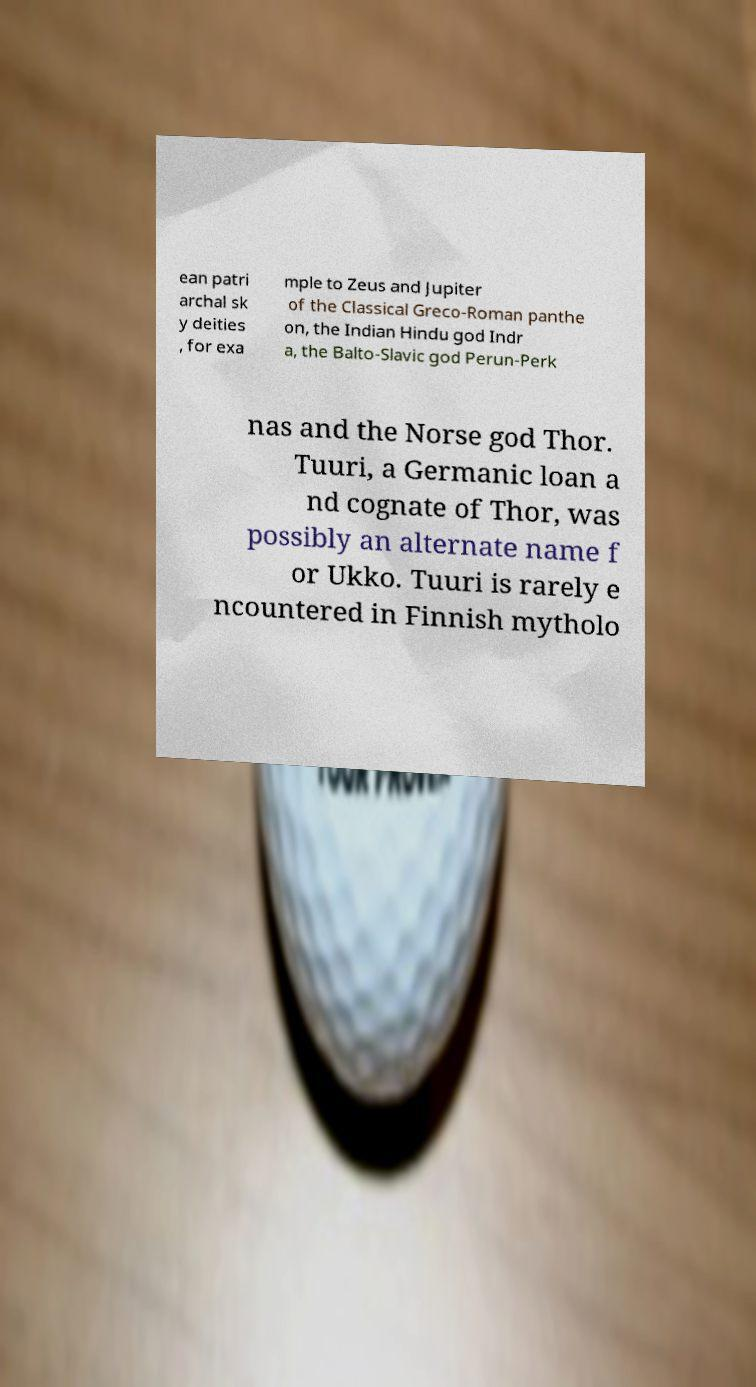For documentation purposes, I need the text within this image transcribed. Could you provide that? ean patri archal sk y deities , for exa mple to Zeus and Jupiter of the Classical Greco-Roman panthe on, the Indian Hindu god Indr a, the Balto-Slavic god Perun-Perk nas and the Norse god Thor. Tuuri, a Germanic loan a nd cognate of Thor, was possibly an alternate name f or Ukko. Tuuri is rarely e ncountered in Finnish mytholo 